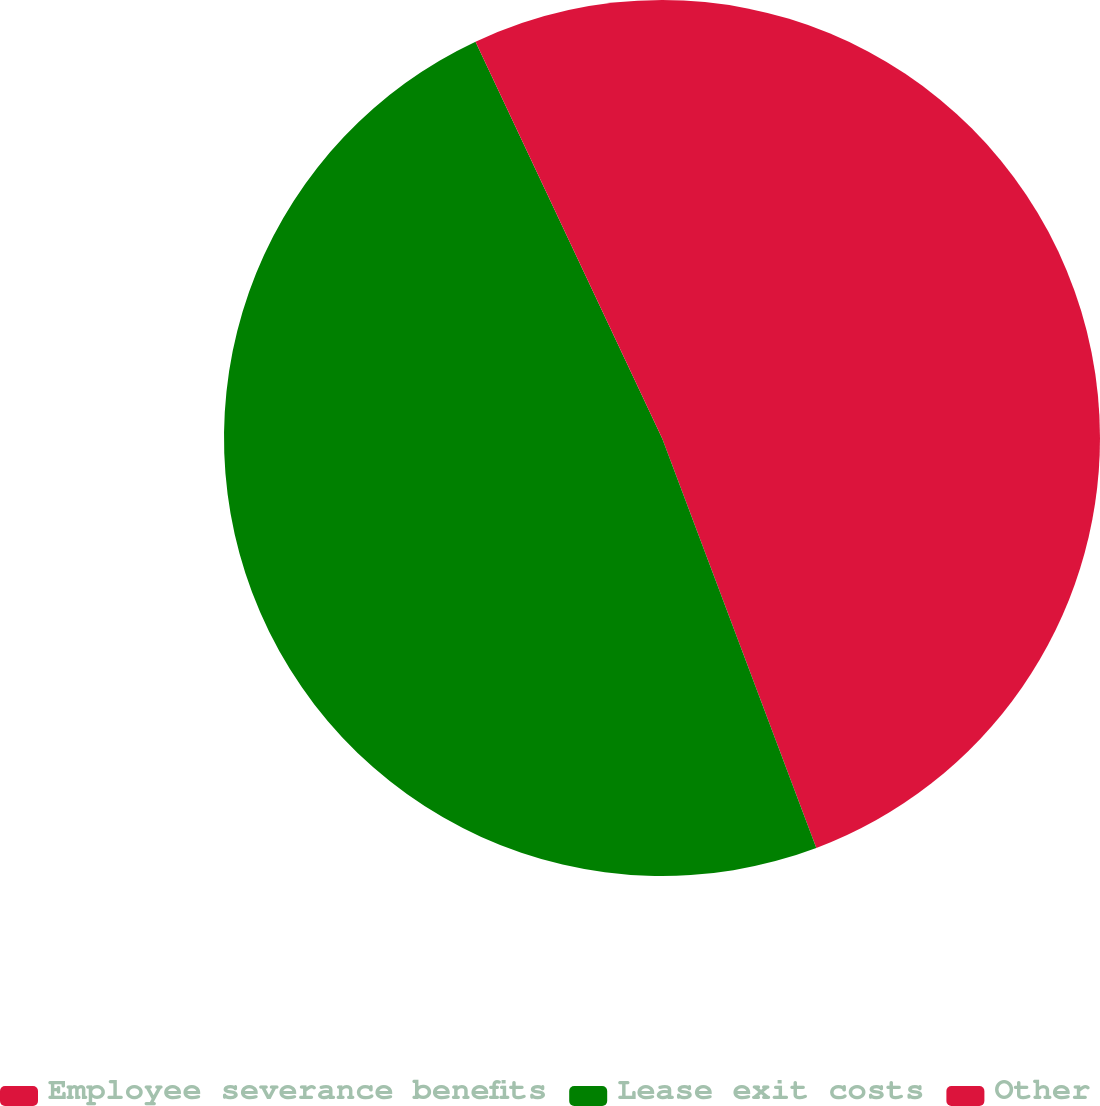<chart> <loc_0><loc_0><loc_500><loc_500><pie_chart><fcel>Employee severance benefits<fcel>Lease exit costs<fcel>Other<nl><fcel>44.27%<fcel>48.73%<fcel>7.0%<nl></chart> 